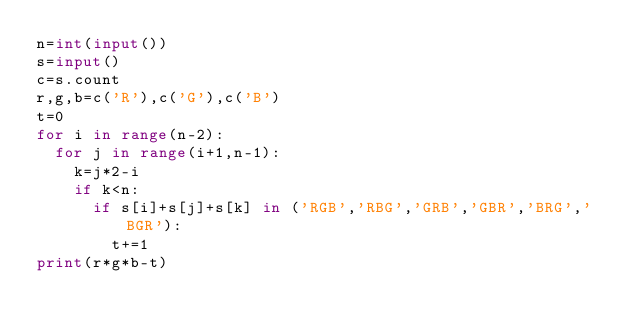Convert code to text. <code><loc_0><loc_0><loc_500><loc_500><_Python_>n=int(input())
s=input()
c=s.count
r,g,b=c('R'),c('G'),c('B')
t=0
for i in range(n-2):
  for j in range(i+1,n-1):
    k=j*2-i
    if k<n:
      if s[i]+s[j]+s[k] in ('RGB','RBG','GRB','GBR','BRG','BGR'):
        t+=1
print(r*g*b-t)</code> 